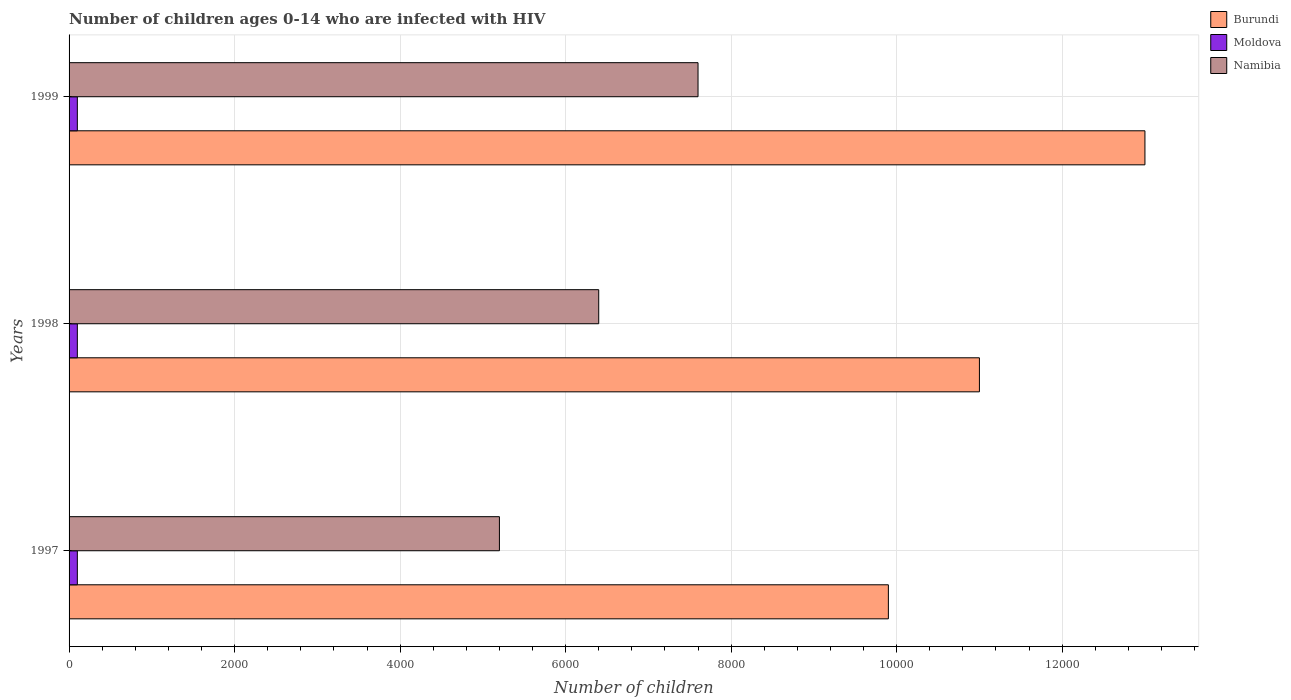How many different coloured bars are there?
Your answer should be very brief. 3. How many bars are there on the 2nd tick from the top?
Your answer should be compact. 3. In how many cases, is the number of bars for a given year not equal to the number of legend labels?
Provide a succinct answer. 0. What is the number of HIV infected children in Burundi in 1999?
Give a very brief answer. 1.30e+04. Across all years, what is the maximum number of HIV infected children in Burundi?
Your response must be concise. 1.30e+04. Across all years, what is the minimum number of HIV infected children in Namibia?
Ensure brevity in your answer.  5200. In which year was the number of HIV infected children in Burundi minimum?
Provide a succinct answer. 1997. What is the total number of HIV infected children in Moldova in the graph?
Offer a terse response. 300. What is the difference between the number of HIV infected children in Namibia in 1997 and that in 1998?
Keep it short and to the point. -1200. What is the difference between the number of HIV infected children in Moldova in 1997 and the number of HIV infected children in Namibia in 1999?
Your response must be concise. -7500. What is the average number of HIV infected children in Namibia per year?
Your answer should be compact. 6400. In the year 1997, what is the difference between the number of HIV infected children in Moldova and number of HIV infected children in Namibia?
Provide a succinct answer. -5100. In how many years, is the number of HIV infected children in Namibia greater than 2800 ?
Give a very brief answer. 3. Is the number of HIV infected children in Namibia in 1997 less than that in 1999?
Your answer should be compact. Yes. Is the difference between the number of HIV infected children in Moldova in 1998 and 1999 greater than the difference between the number of HIV infected children in Namibia in 1998 and 1999?
Your answer should be very brief. Yes. What is the difference between the highest and the second highest number of HIV infected children in Moldova?
Provide a succinct answer. 0. What is the difference between the highest and the lowest number of HIV infected children in Namibia?
Provide a short and direct response. 2400. In how many years, is the number of HIV infected children in Burundi greater than the average number of HIV infected children in Burundi taken over all years?
Your answer should be compact. 1. What does the 2nd bar from the top in 1999 represents?
Give a very brief answer. Moldova. What does the 2nd bar from the bottom in 1999 represents?
Your answer should be very brief. Moldova. Is it the case that in every year, the sum of the number of HIV infected children in Burundi and number of HIV infected children in Moldova is greater than the number of HIV infected children in Namibia?
Your answer should be compact. Yes. Are all the bars in the graph horizontal?
Keep it short and to the point. Yes. How many years are there in the graph?
Make the answer very short. 3. What is the difference between two consecutive major ticks on the X-axis?
Your answer should be very brief. 2000. Does the graph contain grids?
Your response must be concise. Yes. Where does the legend appear in the graph?
Keep it short and to the point. Top right. How many legend labels are there?
Make the answer very short. 3. What is the title of the graph?
Offer a terse response. Number of children ages 0-14 who are infected with HIV. Does "Bahamas" appear as one of the legend labels in the graph?
Make the answer very short. No. What is the label or title of the X-axis?
Keep it short and to the point. Number of children. What is the label or title of the Y-axis?
Give a very brief answer. Years. What is the Number of children in Burundi in 1997?
Your response must be concise. 9900. What is the Number of children of Namibia in 1997?
Make the answer very short. 5200. What is the Number of children of Burundi in 1998?
Your answer should be compact. 1.10e+04. What is the Number of children of Namibia in 1998?
Make the answer very short. 6400. What is the Number of children in Burundi in 1999?
Your answer should be compact. 1.30e+04. What is the Number of children of Namibia in 1999?
Provide a short and direct response. 7600. Across all years, what is the maximum Number of children of Burundi?
Provide a succinct answer. 1.30e+04. Across all years, what is the maximum Number of children in Moldova?
Your answer should be compact. 100. Across all years, what is the maximum Number of children in Namibia?
Make the answer very short. 7600. Across all years, what is the minimum Number of children in Burundi?
Keep it short and to the point. 9900. Across all years, what is the minimum Number of children in Moldova?
Make the answer very short. 100. Across all years, what is the minimum Number of children in Namibia?
Provide a succinct answer. 5200. What is the total Number of children of Burundi in the graph?
Your answer should be compact. 3.39e+04. What is the total Number of children in Moldova in the graph?
Ensure brevity in your answer.  300. What is the total Number of children in Namibia in the graph?
Give a very brief answer. 1.92e+04. What is the difference between the Number of children in Burundi in 1997 and that in 1998?
Provide a short and direct response. -1100. What is the difference between the Number of children of Namibia in 1997 and that in 1998?
Make the answer very short. -1200. What is the difference between the Number of children in Burundi in 1997 and that in 1999?
Your response must be concise. -3100. What is the difference between the Number of children in Moldova in 1997 and that in 1999?
Keep it short and to the point. 0. What is the difference between the Number of children in Namibia in 1997 and that in 1999?
Keep it short and to the point. -2400. What is the difference between the Number of children in Burundi in 1998 and that in 1999?
Offer a terse response. -2000. What is the difference between the Number of children of Moldova in 1998 and that in 1999?
Your answer should be very brief. 0. What is the difference between the Number of children of Namibia in 1998 and that in 1999?
Keep it short and to the point. -1200. What is the difference between the Number of children of Burundi in 1997 and the Number of children of Moldova in 1998?
Your answer should be compact. 9800. What is the difference between the Number of children in Burundi in 1997 and the Number of children in Namibia in 1998?
Keep it short and to the point. 3500. What is the difference between the Number of children of Moldova in 1997 and the Number of children of Namibia in 1998?
Your answer should be compact. -6300. What is the difference between the Number of children in Burundi in 1997 and the Number of children in Moldova in 1999?
Offer a terse response. 9800. What is the difference between the Number of children in Burundi in 1997 and the Number of children in Namibia in 1999?
Give a very brief answer. 2300. What is the difference between the Number of children of Moldova in 1997 and the Number of children of Namibia in 1999?
Your response must be concise. -7500. What is the difference between the Number of children of Burundi in 1998 and the Number of children of Moldova in 1999?
Your answer should be compact. 1.09e+04. What is the difference between the Number of children in Burundi in 1998 and the Number of children in Namibia in 1999?
Provide a short and direct response. 3400. What is the difference between the Number of children in Moldova in 1998 and the Number of children in Namibia in 1999?
Ensure brevity in your answer.  -7500. What is the average Number of children in Burundi per year?
Offer a terse response. 1.13e+04. What is the average Number of children of Moldova per year?
Give a very brief answer. 100. What is the average Number of children of Namibia per year?
Keep it short and to the point. 6400. In the year 1997, what is the difference between the Number of children in Burundi and Number of children in Moldova?
Offer a very short reply. 9800. In the year 1997, what is the difference between the Number of children in Burundi and Number of children in Namibia?
Provide a succinct answer. 4700. In the year 1997, what is the difference between the Number of children of Moldova and Number of children of Namibia?
Your response must be concise. -5100. In the year 1998, what is the difference between the Number of children in Burundi and Number of children in Moldova?
Keep it short and to the point. 1.09e+04. In the year 1998, what is the difference between the Number of children of Burundi and Number of children of Namibia?
Your answer should be very brief. 4600. In the year 1998, what is the difference between the Number of children in Moldova and Number of children in Namibia?
Ensure brevity in your answer.  -6300. In the year 1999, what is the difference between the Number of children in Burundi and Number of children in Moldova?
Keep it short and to the point. 1.29e+04. In the year 1999, what is the difference between the Number of children of Burundi and Number of children of Namibia?
Provide a succinct answer. 5400. In the year 1999, what is the difference between the Number of children in Moldova and Number of children in Namibia?
Your answer should be compact. -7500. What is the ratio of the Number of children of Burundi in 1997 to that in 1998?
Offer a terse response. 0.9. What is the ratio of the Number of children in Namibia in 1997 to that in 1998?
Your answer should be very brief. 0.81. What is the ratio of the Number of children of Burundi in 1997 to that in 1999?
Offer a very short reply. 0.76. What is the ratio of the Number of children in Namibia in 1997 to that in 1999?
Provide a short and direct response. 0.68. What is the ratio of the Number of children of Burundi in 1998 to that in 1999?
Give a very brief answer. 0.85. What is the ratio of the Number of children in Namibia in 1998 to that in 1999?
Offer a terse response. 0.84. What is the difference between the highest and the second highest Number of children in Burundi?
Offer a terse response. 2000. What is the difference between the highest and the second highest Number of children in Moldova?
Offer a very short reply. 0. What is the difference between the highest and the second highest Number of children in Namibia?
Your response must be concise. 1200. What is the difference between the highest and the lowest Number of children in Burundi?
Provide a succinct answer. 3100. What is the difference between the highest and the lowest Number of children of Namibia?
Your answer should be very brief. 2400. 